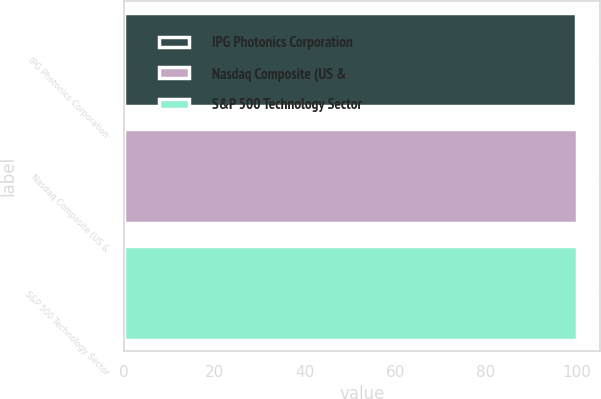Convert chart to OTSL. <chart><loc_0><loc_0><loc_500><loc_500><bar_chart><fcel>IPG Photonics Corporation<fcel>Nasdaq Composite (US &<fcel>S&P 500 Technology Sector<nl><fcel>100<fcel>100.1<fcel>100.2<nl></chart> 